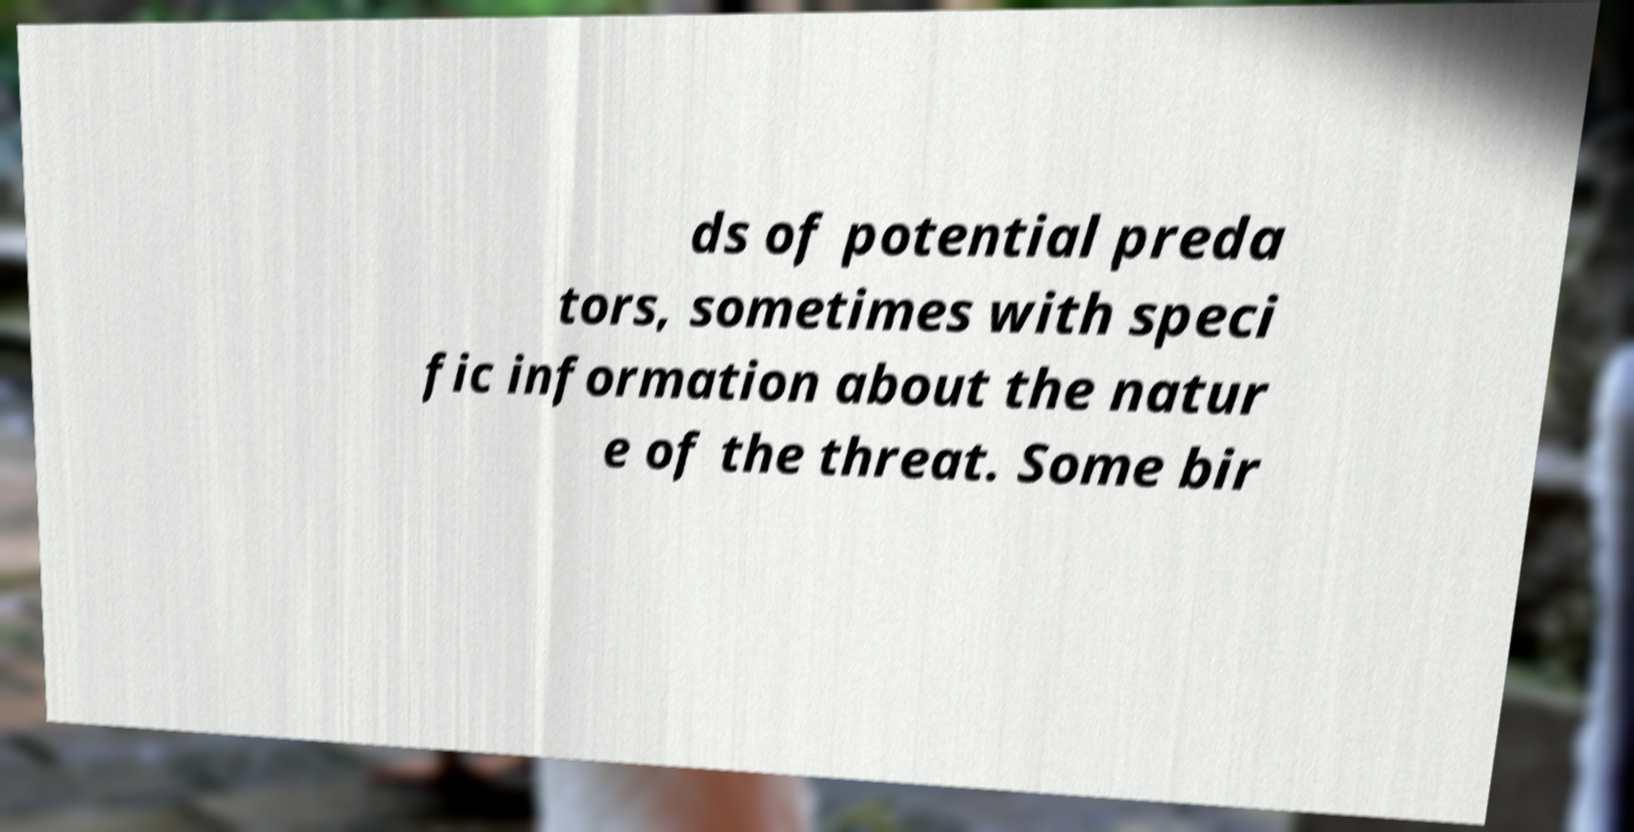There's text embedded in this image that I need extracted. Can you transcribe it verbatim? ds of potential preda tors, sometimes with speci fic information about the natur e of the threat. Some bir 